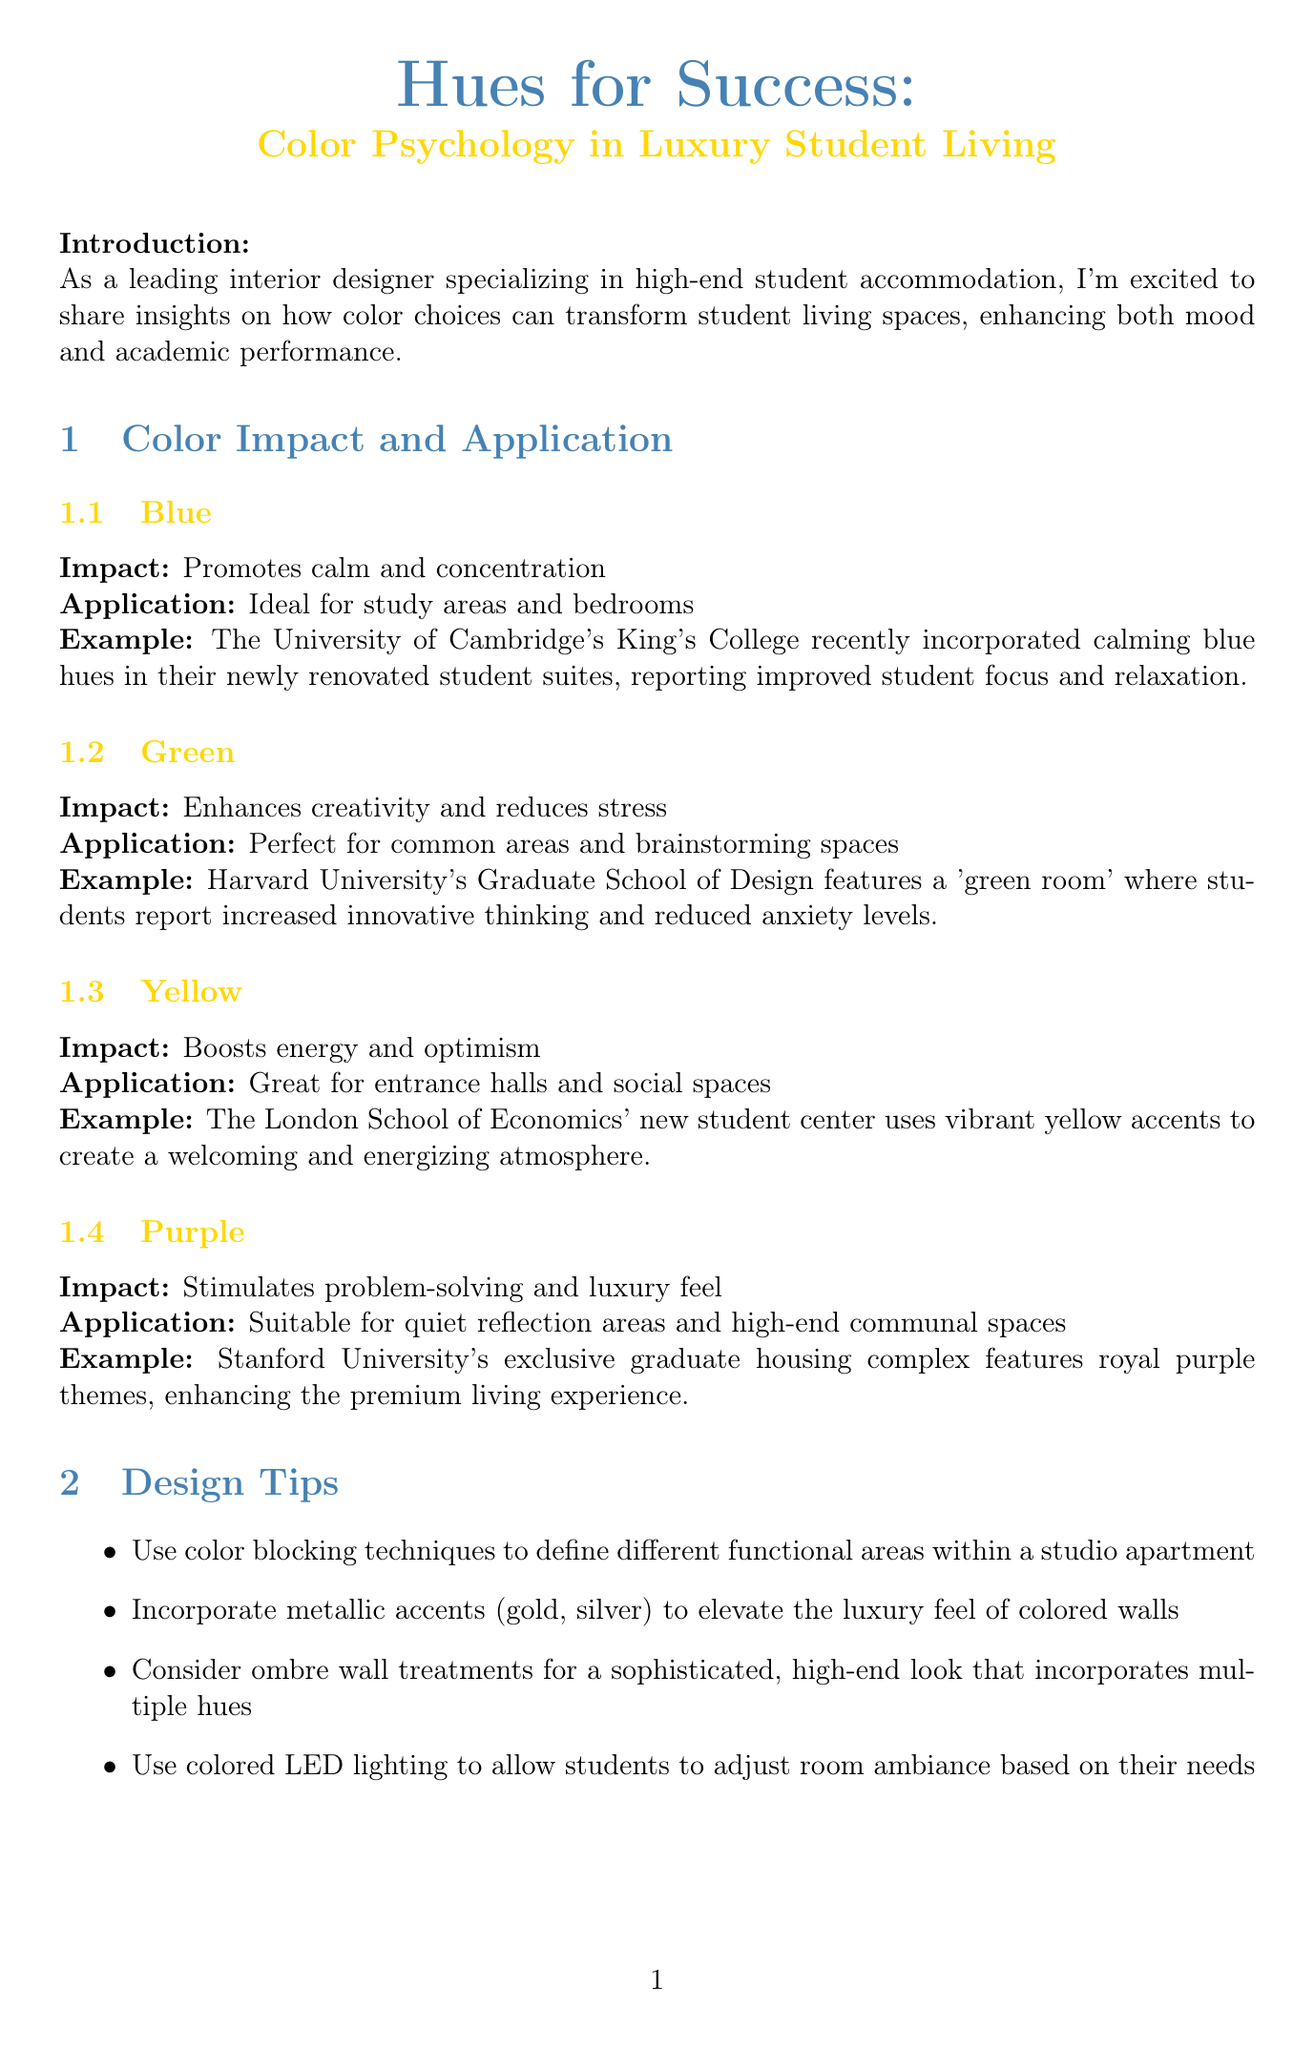What is the title of the newsletter? The title is stated at the beginning of the document and emphasizes the focus on color psychology in luxury student living.
Answer: Hues for Success: Color Psychology in Luxury Student Living What color promotes calm and concentration? The document specifies that blue is the color associated with promoting calm and concentration.
Answer: Blue Which university's graduate school features a 'green room'? The example provided in the document indicates that Harvard University's Graduate School of Design features this room.
Answer: Harvard University What is the percentage increase in student satisfaction at NYU's premium housing? The case study mentions a specific improvement in satisfaction which is quantified.
Answer: 35% What application is suggested for yellow in student living environments? The application of yellow is identified for specific areas within the document relating to student living design.
Answer: Entrance halls and social spaces Which color is suggested for quiet reflection areas? The document notes that purple is suitable for spaces designated for quiet reflection.
Answer: Purple Who provided an expert quote in the newsletter? The expert quote section of the document lists a specific individual affiliated with a university who comments on color psychology.
Answer: Dr. Angela Richardson What is one of the design tips provided in the document? The design tips listed include specific techniques for applying color in student accommodations.
Answer: Use color blocking techniques to define different functional areas within a studio apartment What color was used to enhance focus in individual study spaces at NYU? The outcome of the case study details the specific color chosen to enhance focus in study areas.
Answer: Teal 